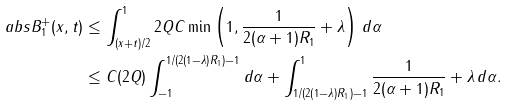<formula> <loc_0><loc_0><loc_500><loc_500>\ a b s { B ^ { + } _ { 1 } ( x , t ) } & \leq \int _ { ( x + t ) / 2 } ^ { 1 } 2 Q C \min \left ( 1 , \frac { 1 } { 2 ( \alpha + 1 ) R _ { 1 } } + \lambda \right ) \, d \alpha \\ & \leq C ( 2 Q ) \int _ { - 1 } ^ { 1 / ( 2 ( 1 - \lambda ) R _ { 1 } ) - 1 } d \alpha + \int _ { 1 / ( 2 ( 1 - \lambda ) R _ { 1 } ) - 1 } ^ { 1 } \frac { 1 } { 2 ( \alpha + 1 ) R _ { 1 } } + \lambda \, d \alpha .</formula> 